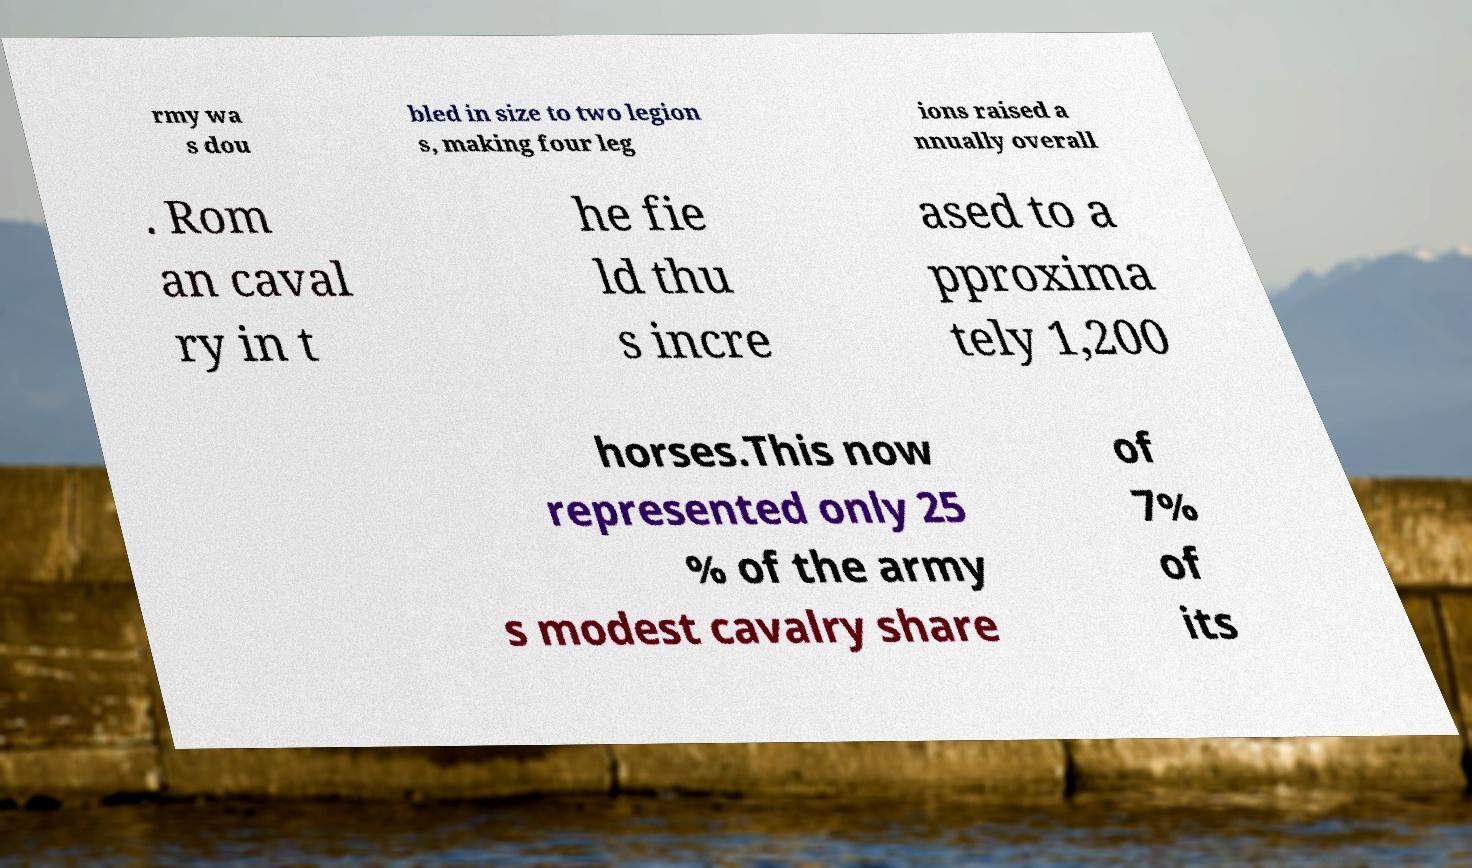I need the written content from this picture converted into text. Can you do that? rmy wa s dou bled in size to two legion s, making four leg ions raised a nnually overall . Rom an caval ry in t he fie ld thu s incre ased to a pproxima tely 1,200 horses.This now represented only 25 % of the army s modest cavalry share of 7% of its 